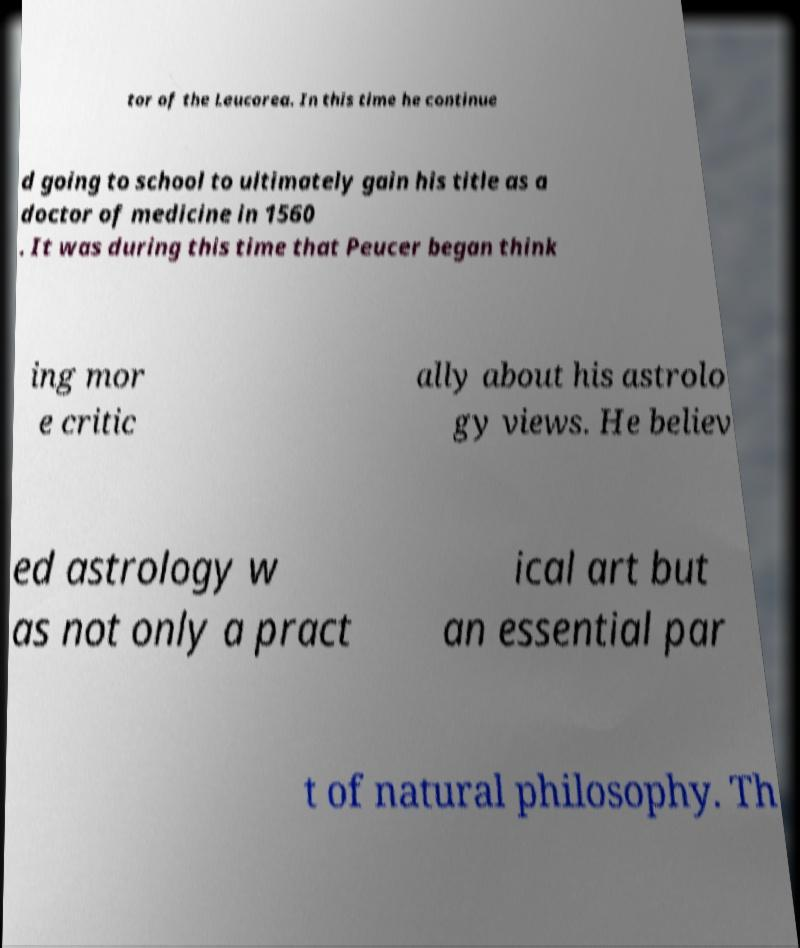Please read and relay the text visible in this image. What does it say? tor of the Leucorea. In this time he continue d going to school to ultimately gain his title as a doctor of medicine in 1560 . It was during this time that Peucer began think ing mor e critic ally about his astrolo gy views. He believ ed astrology w as not only a pract ical art but an essential par t of natural philosophy. Th 